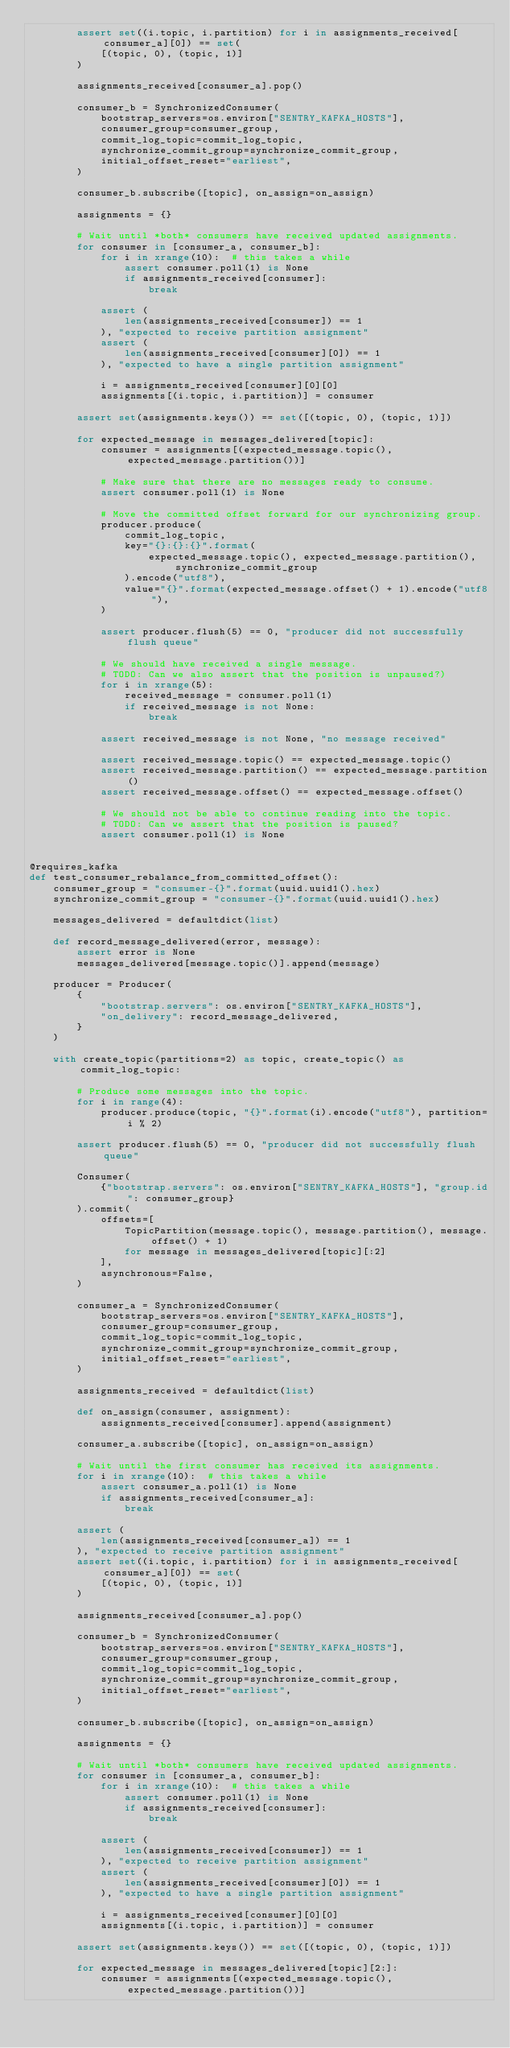<code> <loc_0><loc_0><loc_500><loc_500><_Python_>        assert set((i.topic, i.partition) for i in assignments_received[consumer_a][0]) == set(
            [(topic, 0), (topic, 1)]
        )

        assignments_received[consumer_a].pop()

        consumer_b = SynchronizedConsumer(
            bootstrap_servers=os.environ["SENTRY_KAFKA_HOSTS"],
            consumer_group=consumer_group,
            commit_log_topic=commit_log_topic,
            synchronize_commit_group=synchronize_commit_group,
            initial_offset_reset="earliest",
        )

        consumer_b.subscribe([topic], on_assign=on_assign)

        assignments = {}

        # Wait until *both* consumers have received updated assignments.
        for consumer in [consumer_a, consumer_b]:
            for i in xrange(10):  # this takes a while
                assert consumer.poll(1) is None
                if assignments_received[consumer]:
                    break

            assert (
                len(assignments_received[consumer]) == 1
            ), "expected to receive partition assignment"
            assert (
                len(assignments_received[consumer][0]) == 1
            ), "expected to have a single partition assignment"

            i = assignments_received[consumer][0][0]
            assignments[(i.topic, i.partition)] = consumer

        assert set(assignments.keys()) == set([(topic, 0), (topic, 1)])

        for expected_message in messages_delivered[topic]:
            consumer = assignments[(expected_message.topic(), expected_message.partition())]

            # Make sure that there are no messages ready to consume.
            assert consumer.poll(1) is None

            # Move the committed offset forward for our synchronizing group.
            producer.produce(
                commit_log_topic,
                key="{}:{}:{}".format(
                    expected_message.topic(), expected_message.partition(), synchronize_commit_group
                ).encode("utf8"),
                value="{}".format(expected_message.offset() + 1).encode("utf8"),
            )

            assert producer.flush(5) == 0, "producer did not successfully flush queue"

            # We should have received a single message.
            # TODO: Can we also assert that the position is unpaused?)
            for i in xrange(5):
                received_message = consumer.poll(1)
                if received_message is not None:
                    break

            assert received_message is not None, "no message received"

            assert received_message.topic() == expected_message.topic()
            assert received_message.partition() == expected_message.partition()
            assert received_message.offset() == expected_message.offset()

            # We should not be able to continue reading into the topic.
            # TODO: Can we assert that the position is paused?
            assert consumer.poll(1) is None


@requires_kafka
def test_consumer_rebalance_from_committed_offset():
    consumer_group = "consumer-{}".format(uuid.uuid1().hex)
    synchronize_commit_group = "consumer-{}".format(uuid.uuid1().hex)

    messages_delivered = defaultdict(list)

    def record_message_delivered(error, message):
        assert error is None
        messages_delivered[message.topic()].append(message)

    producer = Producer(
        {
            "bootstrap.servers": os.environ["SENTRY_KAFKA_HOSTS"],
            "on_delivery": record_message_delivered,
        }
    )

    with create_topic(partitions=2) as topic, create_topic() as commit_log_topic:

        # Produce some messages into the topic.
        for i in range(4):
            producer.produce(topic, "{}".format(i).encode("utf8"), partition=i % 2)

        assert producer.flush(5) == 0, "producer did not successfully flush queue"

        Consumer(
            {"bootstrap.servers": os.environ["SENTRY_KAFKA_HOSTS"], "group.id": consumer_group}
        ).commit(
            offsets=[
                TopicPartition(message.topic(), message.partition(), message.offset() + 1)
                for message in messages_delivered[topic][:2]
            ],
            asynchronous=False,
        )

        consumer_a = SynchronizedConsumer(
            bootstrap_servers=os.environ["SENTRY_KAFKA_HOSTS"],
            consumer_group=consumer_group,
            commit_log_topic=commit_log_topic,
            synchronize_commit_group=synchronize_commit_group,
            initial_offset_reset="earliest",
        )

        assignments_received = defaultdict(list)

        def on_assign(consumer, assignment):
            assignments_received[consumer].append(assignment)

        consumer_a.subscribe([topic], on_assign=on_assign)

        # Wait until the first consumer has received its assignments.
        for i in xrange(10):  # this takes a while
            assert consumer_a.poll(1) is None
            if assignments_received[consumer_a]:
                break

        assert (
            len(assignments_received[consumer_a]) == 1
        ), "expected to receive partition assignment"
        assert set((i.topic, i.partition) for i in assignments_received[consumer_a][0]) == set(
            [(topic, 0), (topic, 1)]
        )

        assignments_received[consumer_a].pop()

        consumer_b = SynchronizedConsumer(
            bootstrap_servers=os.environ["SENTRY_KAFKA_HOSTS"],
            consumer_group=consumer_group,
            commit_log_topic=commit_log_topic,
            synchronize_commit_group=synchronize_commit_group,
            initial_offset_reset="earliest",
        )

        consumer_b.subscribe([topic], on_assign=on_assign)

        assignments = {}

        # Wait until *both* consumers have received updated assignments.
        for consumer in [consumer_a, consumer_b]:
            for i in xrange(10):  # this takes a while
                assert consumer.poll(1) is None
                if assignments_received[consumer]:
                    break

            assert (
                len(assignments_received[consumer]) == 1
            ), "expected to receive partition assignment"
            assert (
                len(assignments_received[consumer][0]) == 1
            ), "expected to have a single partition assignment"

            i = assignments_received[consumer][0][0]
            assignments[(i.topic, i.partition)] = consumer

        assert set(assignments.keys()) == set([(topic, 0), (topic, 1)])

        for expected_message in messages_delivered[topic][2:]:
            consumer = assignments[(expected_message.topic(), expected_message.partition())]
</code> 